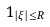<formula> <loc_0><loc_0><loc_500><loc_500>1 _ { | \xi | \leq R }</formula> 